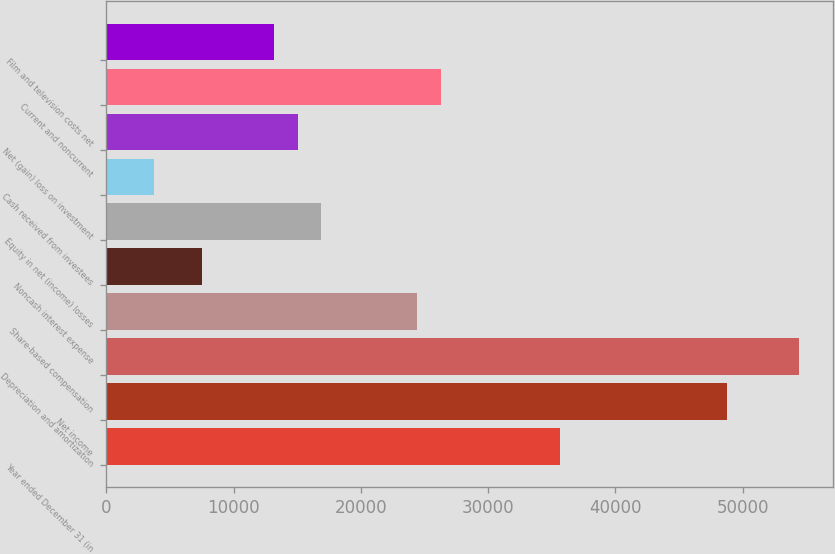Convert chart. <chart><loc_0><loc_0><loc_500><loc_500><bar_chart><fcel>Year ended December 31 (in<fcel>Net income<fcel>Depreciation and amortization<fcel>Share-based compensation<fcel>Noncash interest expense<fcel>Equity in net (income) losses<fcel>Cash received from investees<fcel>Net (gain) loss on investment<fcel>Current and noncurrent<fcel>Film and television costs net<nl><fcel>35645.8<fcel>48765.2<fcel>54387.8<fcel>24400.6<fcel>7532.8<fcel>16903.8<fcel>3784.4<fcel>15029.6<fcel>26274.8<fcel>13155.4<nl></chart> 